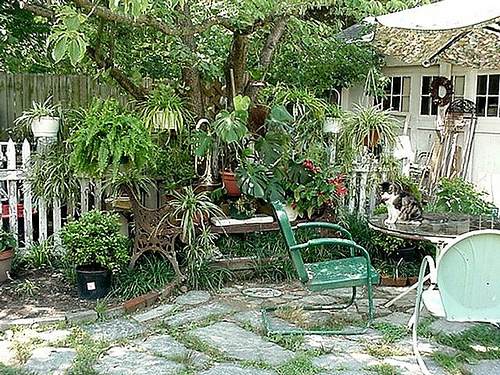Describe the objects in this image and their specific colors. I can see chair in black, teal, darkgray, and gray tones, chair in black, ivory, lightblue, darkgray, and beige tones, potted plant in black, darkgreen, and green tones, potted plant in black, ivory, gray, and darkgreen tones, and potted plant in black, darkgreen, and green tones in this image. 